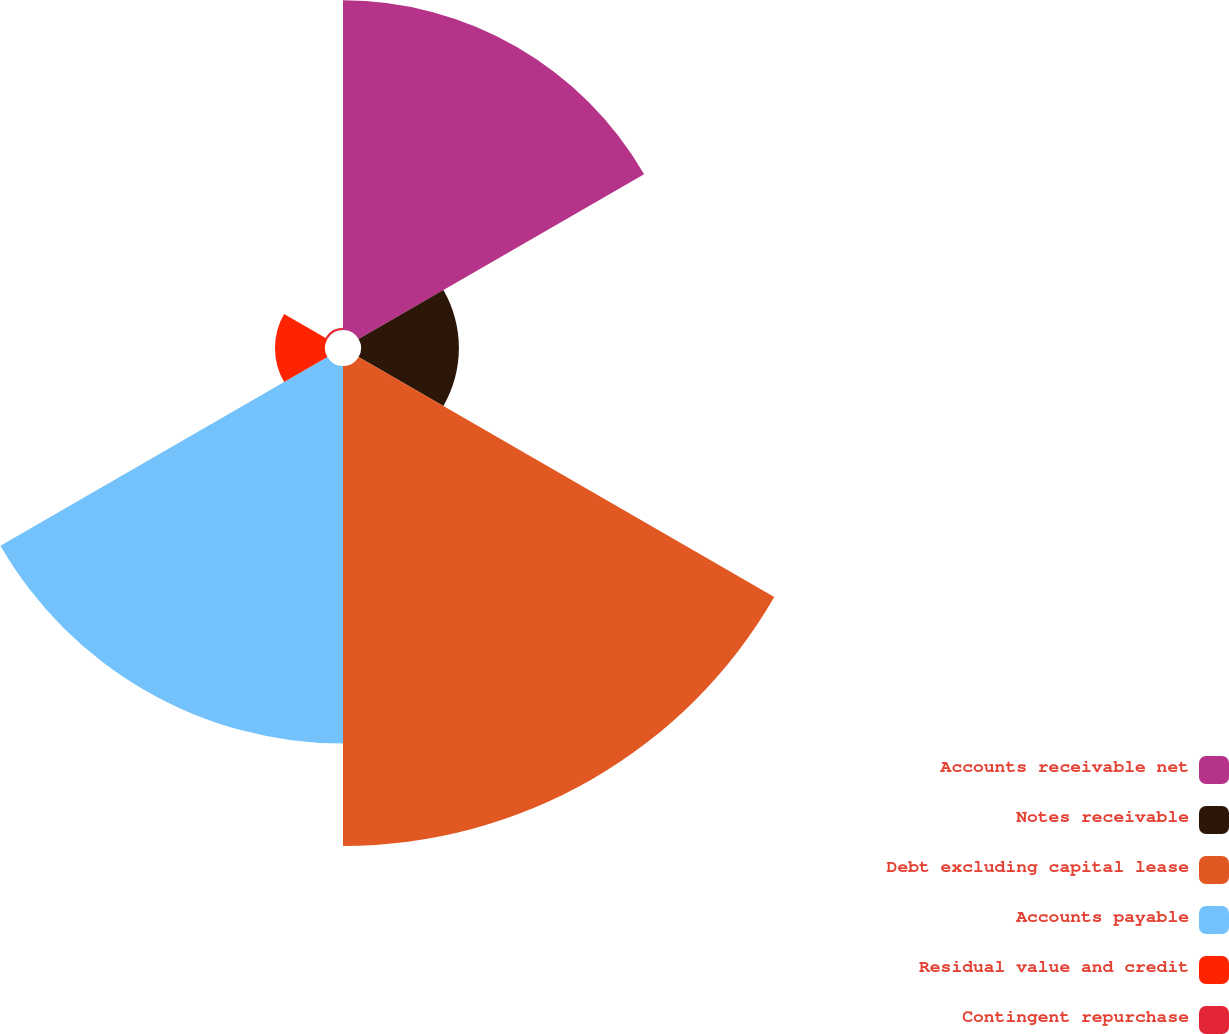Convert chart. <chart><loc_0><loc_0><loc_500><loc_500><pie_chart><fcel>Accounts receivable net<fcel>Notes receivable<fcel>Debt excluding capital lease<fcel>Accounts payable<fcel>Residual value and credit<fcel>Contingent repurchase<nl><fcel>24.65%<fcel>7.32%<fcel>35.89%<fcel>28.23%<fcel>3.74%<fcel>0.17%<nl></chart> 